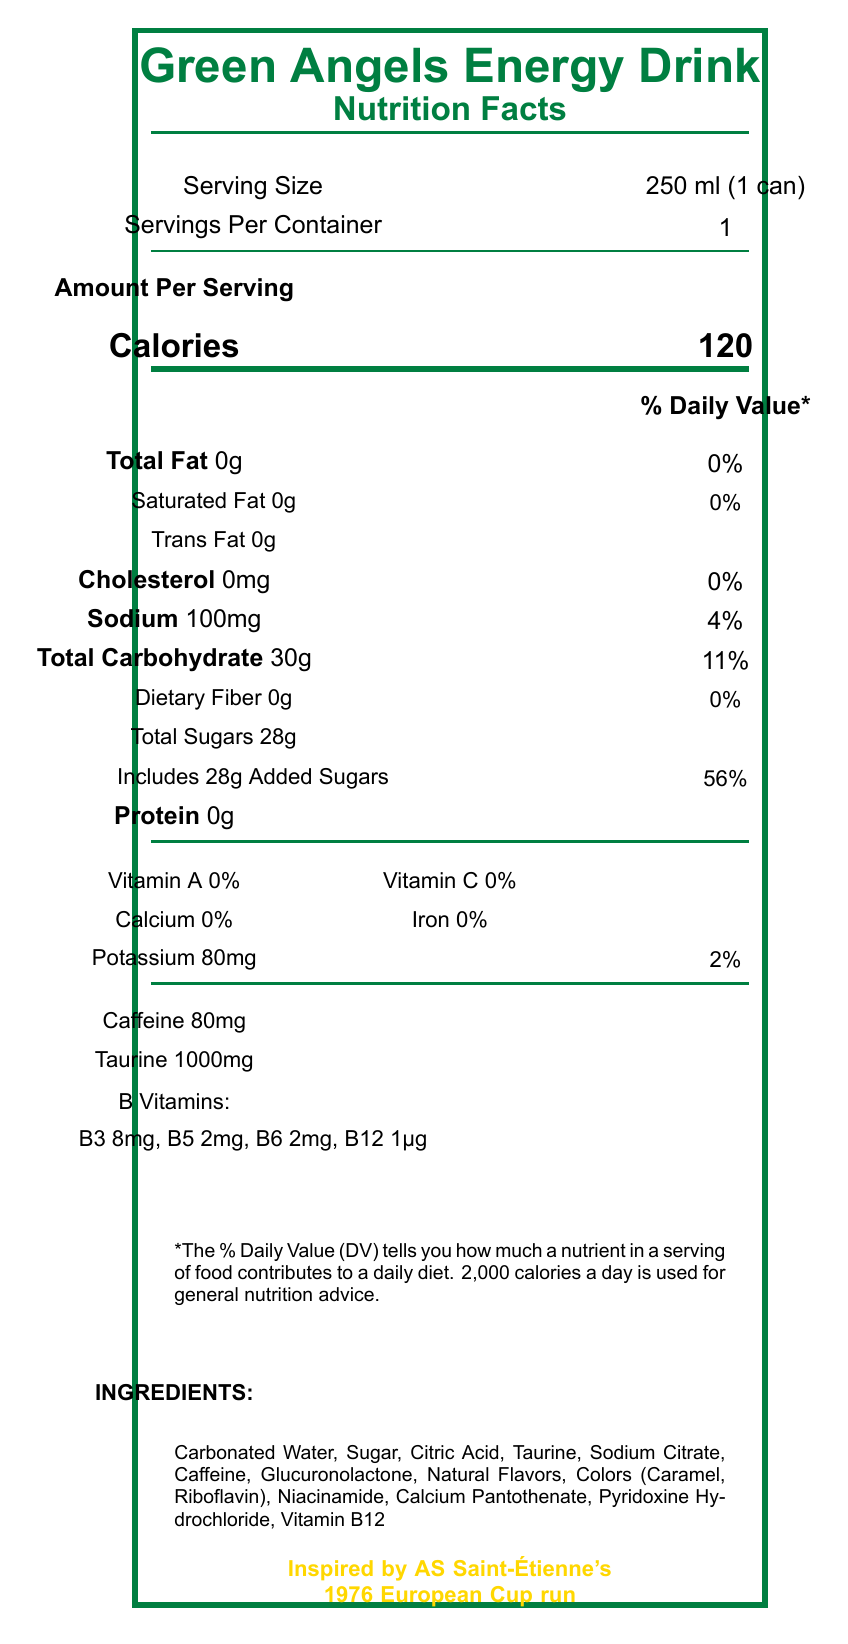what is the serving size of the Green Angels Energy Drink? The serving size is clearly mentioned under the "Serving Size" section of the document.
Answer: 250 ml (1 can) how many calories are in one can of this energy drink? The number of calories per serving is provided in the "Amount Per Serving" section.
Answer: 120 how much sodium is in one serving? The sodium content per serving is listed in the section detailing the nutrient amounts.
Answer: 100mg what is the percentage of Daily Value for Total Carbohydrate? The percentage Daily Value for Total Carbohydrate is listed next to the carbohydrate amount.
Answer: 11% what special feature is highlighted on the can related to AS Saint-Étienne? This special feature is listed at the bottom in gold text.
Answer: Inspired by AS Saint-Étienne's 1976 European Cup run which of the following vitamins does Green Angels Energy Drink contain? A. Vitamin A B. Vitamin C C. Vitamin B6 D. Vitamin D The document lists Vitamin B6 as one of the B vitamins included.
Answer: C what is the amount of caffeine in the drink? A. 50mg B. 60mg C. 70mg D. 80mg The document specifies that the drink contains 80mg of caffeine.
Answer: D does the drink contain any cholesterol? The document states that it contains 0mg of cholesterol.
Answer: No what are the total sugars included in the drink? Under the Total Sugars section, it specifies that the drink includes 28g of total sugars.
Answer: 28g is this drink recommended for children? The disclaimer clearly mentions that it is not recommended for children.
Answer: No summarize the main features of the Green Angels Energy Drink The document mostly centers on the detailed nutritional information, special features related to AS Saint-Étienne, and important consumption instructions.
Answer: The Green Angels Energy Drink is a 250 ml (1 can) energy drink inspired by AS Saint-Étienne's 1976 European Cup run. It contains 120 calories, various B vitamins, 80mg of caffeine, and 28g of total sugars among other ingredients. It is highlighted with green color reminiscent of Les Verts' iconic jerseys and features historical ASSE statistics on limited edition cans. It is manufactured by Stéphanoise Beverages and contains instructions and warnings about its consumption. what historical statistic is displayed on the can? The document mentions that each can displays a random historical ASSE statistic, but does not specify which one.
Answer: I don't know 